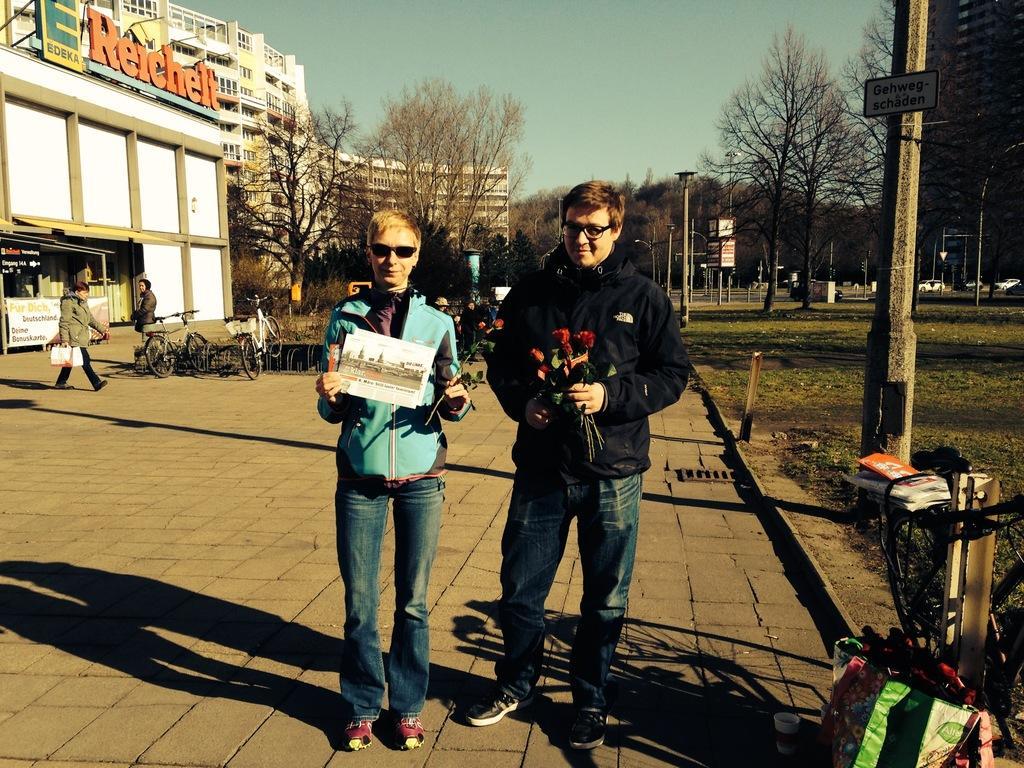Please provide a concise description of this image. This picture is clicked outside. In the center we can see the two persons holding some objects and standing on the ground and we can see there are some objects placed on the ground and we can see the bicycles and group of people. In the background we can see the sky, trees, buildings, text on the boards and the text attached to the building and we can see the green grass, vehicles, metal rods, lampposts and many other objects. 